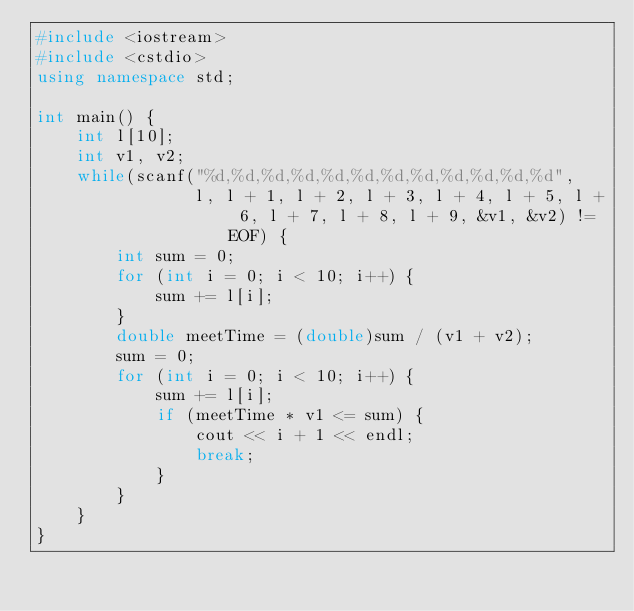Convert code to text. <code><loc_0><loc_0><loc_500><loc_500><_C++_>#include <iostream>
#include <cstdio>
using namespace std;

int main() {
    int l[10];
    int v1, v2;
    while(scanf("%d,%d,%d,%d,%d,%d,%d,%d,%d,%d,%d,%d",
                l, l + 1, l + 2, l + 3, l + 4, l + 5, l + 6, l + 7, l + 8, l + 9, &v1, &v2) != EOF) {
        int sum = 0;
        for (int i = 0; i < 10; i++) {
            sum += l[i];
        }
        double meetTime = (double)sum / (v1 + v2);
        sum = 0;
        for (int i = 0; i < 10; i++) {
            sum += l[i];
            if (meetTime * v1 <= sum) {
                cout << i + 1 << endl;
                break;
            }
        }
    }
}</code> 